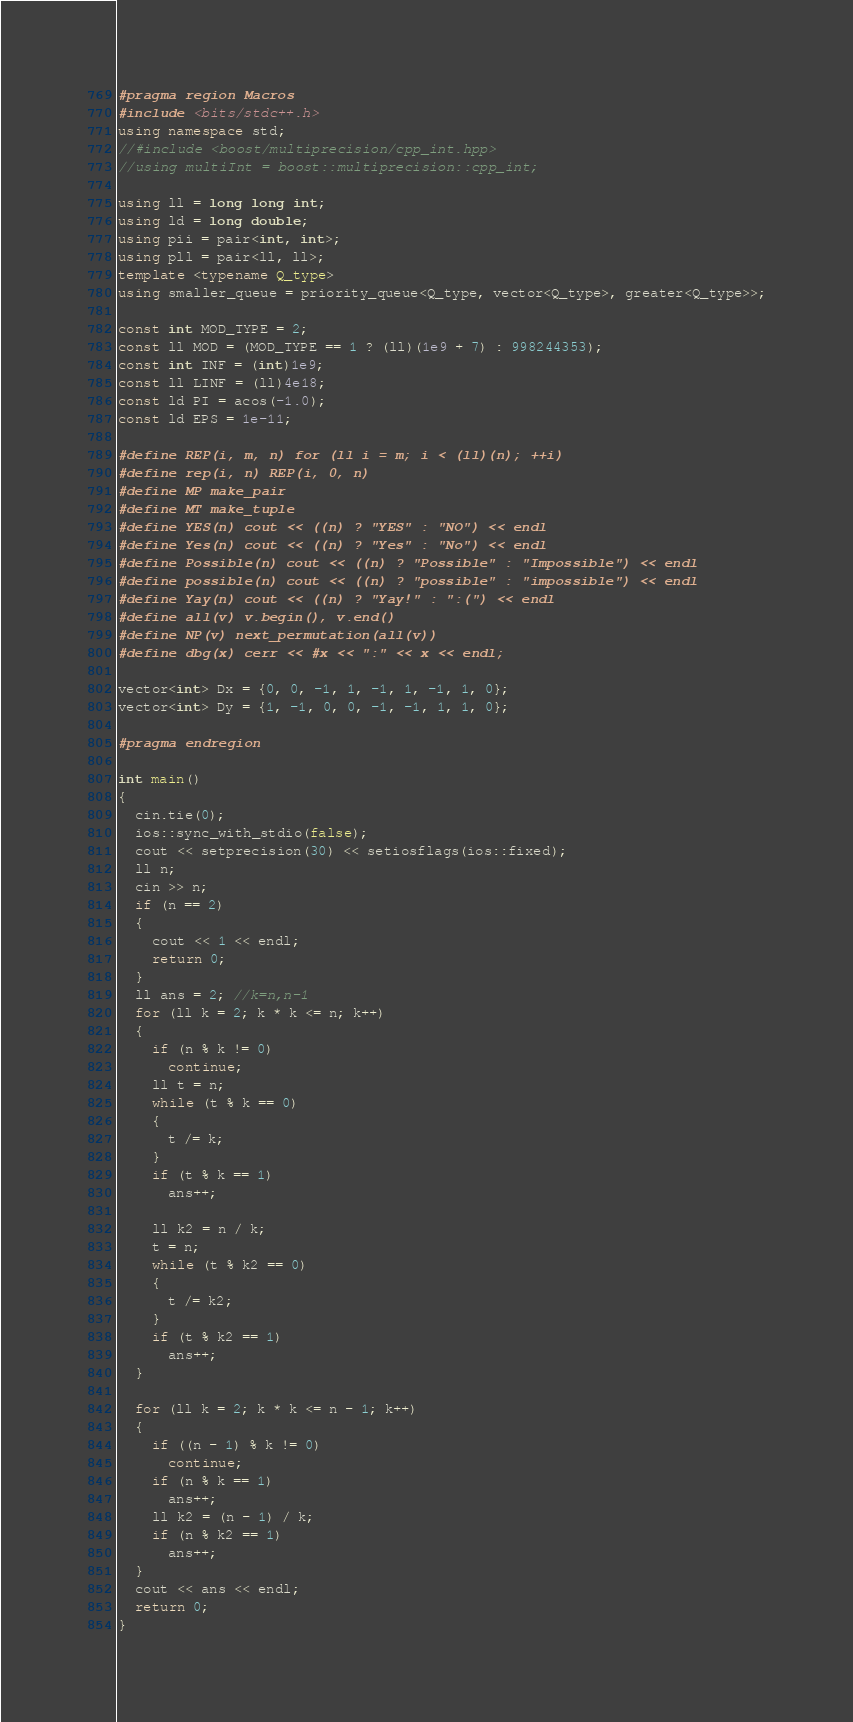Convert code to text. <code><loc_0><loc_0><loc_500><loc_500><_C++_>#pragma region Macros
#include <bits/stdc++.h>
using namespace std;
//#include <boost/multiprecision/cpp_int.hpp>
//using multiInt = boost::multiprecision::cpp_int;

using ll = long long int;
using ld = long double;
using pii = pair<int, int>;
using pll = pair<ll, ll>;
template <typename Q_type>
using smaller_queue = priority_queue<Q_type, vector<Q_type>, greater<Q_type>>;

const int MOD_TYPE = 2;
const ll MOD = (MOD_TYPE == 1 ? (ll)(1e9 + 7) : 998244353);
const int INF = (int)1e9;
const ll LINF = (ll)4e18;
const ld PI = acos(-1.0);
const ld EPS = 1e-11;

#define REP(i, m, n) for (ll i = m; i < (ll)(n); ++i)
#define rep(i, n) REP(i, 0, n)
#define MP make_pair
#define MT make_tuple
#define YES(n) cout << ((n) ? "YES" : "NO") << endl
#define Yes(n) cout << ((n) ? "Yes" : "No") << endl
#define Possible(n) cout << ((n) ? "Possible" : "Impossible") << endl
#define possible(n) cout << ((n) ? "possible" : "impossible") << endl
#define Yay(n) cout << ((n) ? "Yay!" : ":(") << endl
#define all(v) v.begin(), v.end()
#define NP(v) next_permutation(all(v))
#define dbg(x) cerr << #x << ":" << x << endl;

vector<int> Dx = {0, 0, -1, 1, -1, 1, -1, 1, 0};
vector<int> Dy = {1, -1, 0, 0, -1, -1, 1, 1, 0};

#pragma endregion

int main()
{
  cin.tie(0);
  ios::sync_with_stdio(false);
  cout << setprecision(30) << setiosflags(ios::fixed);
  ll n;
  cin >> n;
  if (n == 2)
  {
    cout << 1 << endl;
    return 0;
  }
  ll ans = 2; //k=n,n-1
  for (ll k = 2; k * k <= n; k++)
  {
    if (n % k != 0)
      continue;
    ll t = n;
    while (t % k == 0)
    {
      t /= k;
    }
    if (t % k == 1)
      ans++;

    ll k2 = n / k;
    t = n;
    while (t % k2 == 0)
    {
      t /= k2;
    }
    if (t % k2 == 1)
      ans++;
  }

  for (ll k = 2; k * k <= n - 1; k++)
  {
    if ((n - 1) % k != 0)
      continue;
    if (n % k == 1)
      ans++;
    ll k2 = (n - 1) / k;
    if (n % k2 == 1)
      ans++;
  }
  cout << ans << endl;
  return 0;
}
</code> 